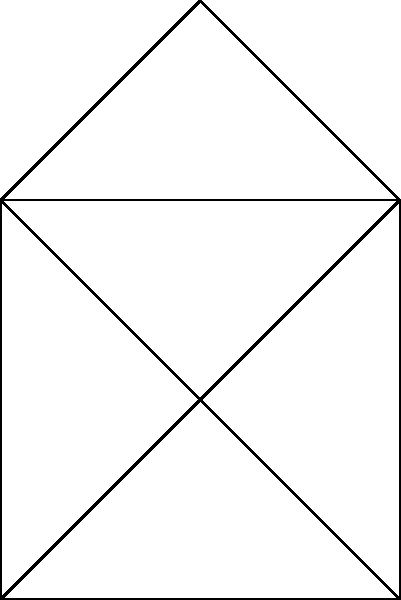In your bar's social network diagram, regular customers are represented as nodes, and their friendships as edges. The diagram shows 6 customers (A to F) and their connections. What is the degree of node A, and what does this represent in the context of your bar's social network? To answer this question, we need to follow these steps:

1. Understand the concept of degree in graph theory:
   - The degree of a node is the number of edges connected to it.
   - In this context, it represents the number of friendships a customer has within the bar's social network.

2. Identify node A in the diagram:
   - Node A is located at the center of the diagram.

3. Count the number of edges connected to node A:
   - Edge A-B
   - Edge A-C
   - Edge A-D
   - Edge A-E

4. Sum up the total number of edges:
   - Total edges connected to A = 4

5. Interpret the result:
   - The degree of node A is 4.
   - This means that customer A has direct connections (friendships) with 4 other regular customers in the bar.

In the context of the bar's social network, this indicates that customer A is quite social and well-connected, potentially playing a central role in the bar's community. They might be a long-time regular or someone who easily makes friends with other patrons.
Answer: 4; number of direct friendships customer A has in the bar's social network 